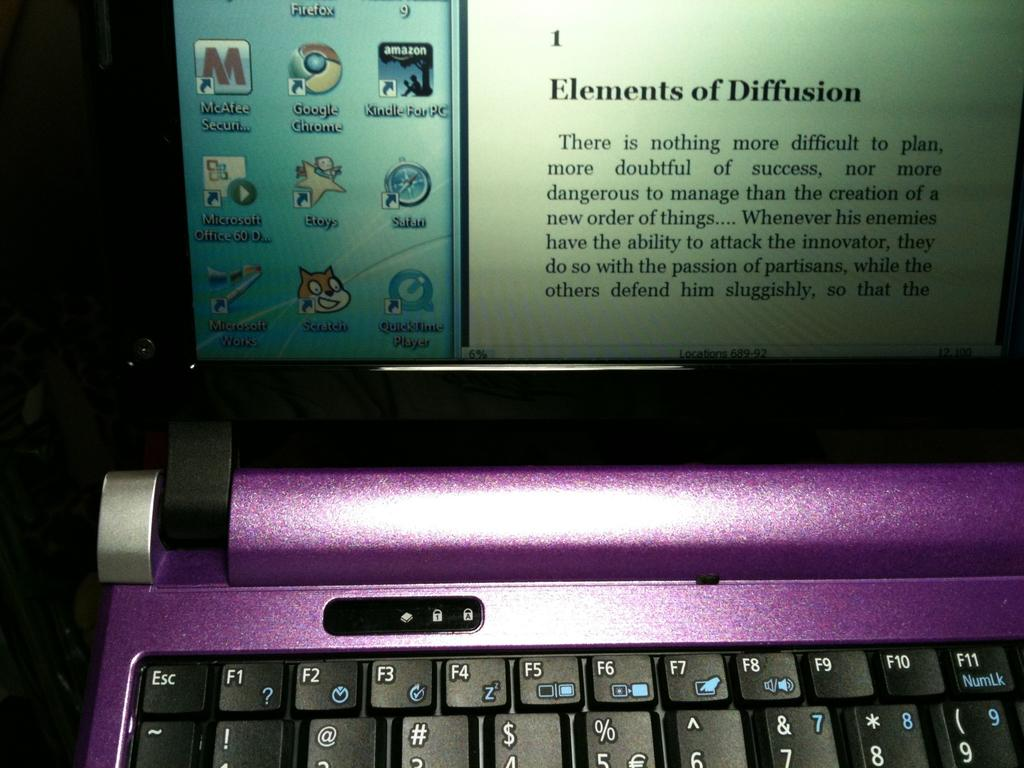<image>
Present a compact description of the photo's key features. A purple flip screen computer has a paragraph on Elements of Diffusion on screen. 